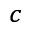<formula> <loc_0><loc_0><loc_500><loc_500>^ { c }</formula> 